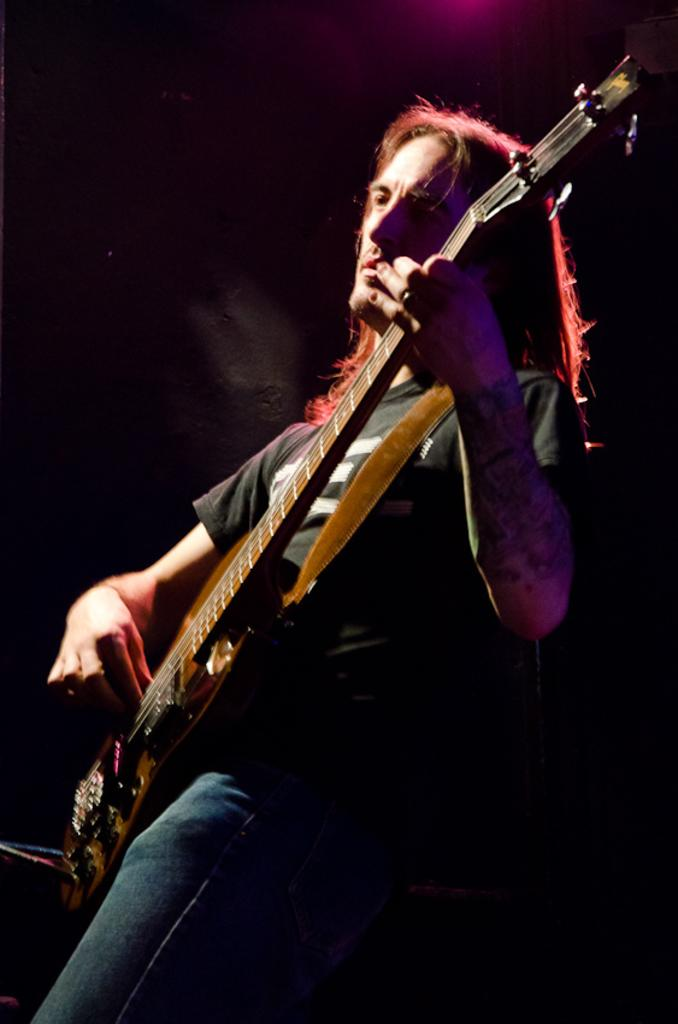What is the main subject of the image? There is a person in the image. What is the person doing in the image? The person is playing a guitar. What type of nail polish is the person wearing on their fingers in the image? There is no indication of nail polish or fingers in the image, as it features a person playing a guitar. 